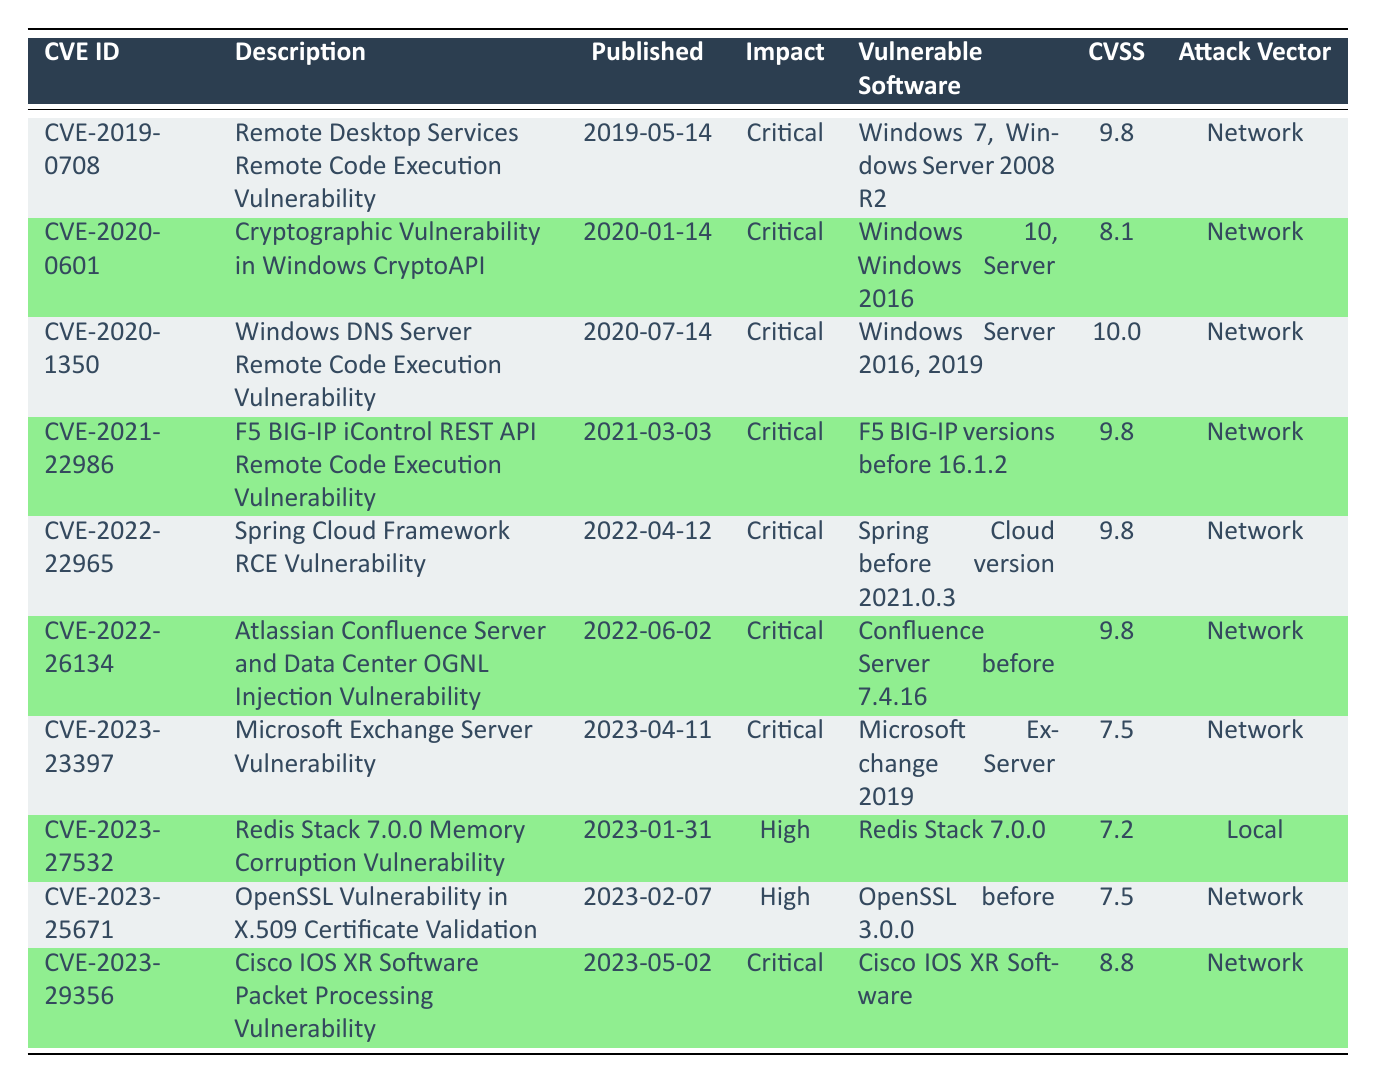What is the CVSS score of CVE-2020-1350? The CVSS score for CVE-2020-1350 is mentioned in the table under the "CVSS" column corresponding to that CVE ID. It shows a score of 10.0.
Answer: 10.0 Which vulnerabilities have a critical impact? By reviewing the "Impact" column in the table, the rows with "Critical" listed under that column indicate they are critical vulnerabilities. All entries except for CVE-2023-27532 and CVE-2023-25671 are critical vulnerabilities.
Answer: 7 What is the description of CVE-2023-25671? The description can be found in the "Description" column next to the CVE ID CVE-2023-25671, which states it relates to an OpenSSL vulnerability in X.509 certificate validation.
Answer: OpenSSL Vulnerability in X.509 Certificate Validation Is there a CVE for Microsoft Exchange Server published in 2023? Checking the table for the software "Microsoft Exchange Server" and the "Published" date column, CVE-2023-23397 indicates it is indeed listed as a Microsoft Exchange Server Vulnerability, published on 2023-04-11.
Answer: Yes How many total vulnerabilities have a CVSS score higher than 9? Count the vulnerabilities with a CVSS score greater than 9. The entries CVE-2019-0708, CVE-2020-1350, CVE-2021-22986, CVE-2022-22965, and CVE-2022-26134 all fit this criterion, totaling 5.
Answer: 5 What is the range of CVSS scores for vulnerabilities with a critical impact? To find the range, identify the highest and lowest CVSS scores for the vulnerabilities marked as critical: 10.0 (CVE-2020-1350) and 7.5 (CVE-2023-23397). The range is from 7.5 to 10.0.
Answer: 7.5 to 10.0 Are there any vulnerabilities affecting multiple software versions listed? Reviewing the "Vulnerable Software" column, both CVE-2020-1350 (Windows Server 2016 and 2019) and CVE-2021-22986 (F5 BIG-IP versions before 16.1.2) affect multiple versions of vulnerable software.
Answer: Yes Which vulnerability has the longest publication date in the table? The published dates can be examined in the "Published" column. The earliest date in the table is 2019-05-14, corresponding to CVE-2019-0708.
Answer: CVE-2019-0708 What is the difference between the highest and lowest CVSS scores across all vulnerabilities? Identify the highest score (10.0 from CVE-2020-1350) and the lowest score (7.2 from CVE-2023-27532). The difference is calculated as 10.0 - 7.2 = 2.8.
Answer: 2.8 